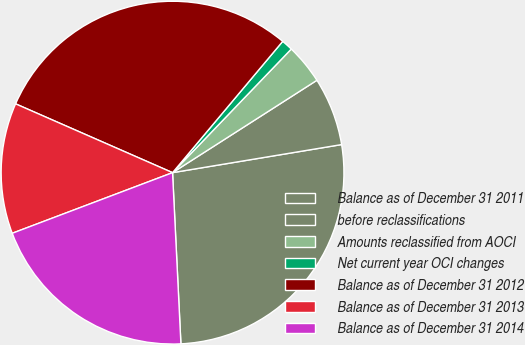Convert chart to OTSL. <chart><loc_0><loc_0><loc_500><loc_500><pie_chart><fcel>Balance as of December 31 2011<fcel>before reclassifications<fcel>Amounts reclassified from AOCI<fcel>Net current year OCI changes<fcel>Balance as of December 31 2012<fcel>Balance as of December 31 2013<fcel>Balance as of December 31 2014<nl><fcel>26.84%<fcel>6.44%<fcel>3.76%<fcel>1.07%<fcel>29.53%<fcel>12.33%<fcel>20.02%<nl></chart> 